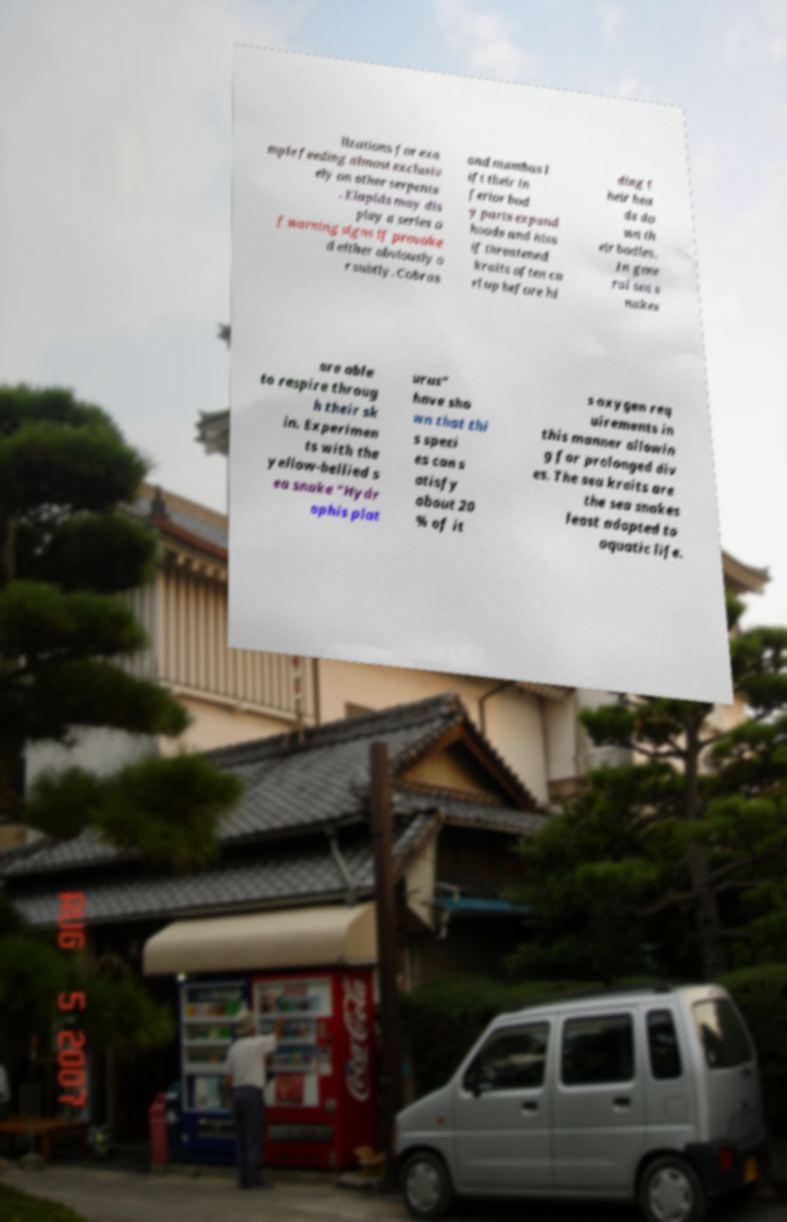Please read and relay the text visible in this image. What does it say? lizations for exa mple feeding almost exclusiv ely on other serpents . Elapids may dis play a series o f warning signs if provoke d either obviously o r subtly. Cobras and mambas l ift their in ferior bod y parts expand hoods and hiss if threatened kraits often cu rl up before hi ding t heir hea ds do wn th eir bodies. In gene ral sea s nakes are able to respire throug h their sk in. Experimen ts with the yellow-bellied s ea snake "Hydr ophis plat urus" have sho wn that thi s speci es can s atisfy about 20 % of it s oxygen req uirements in this manner allowin g for prolonged div es. The sea kraits are the sea snakes least adapted to aquatic life. 